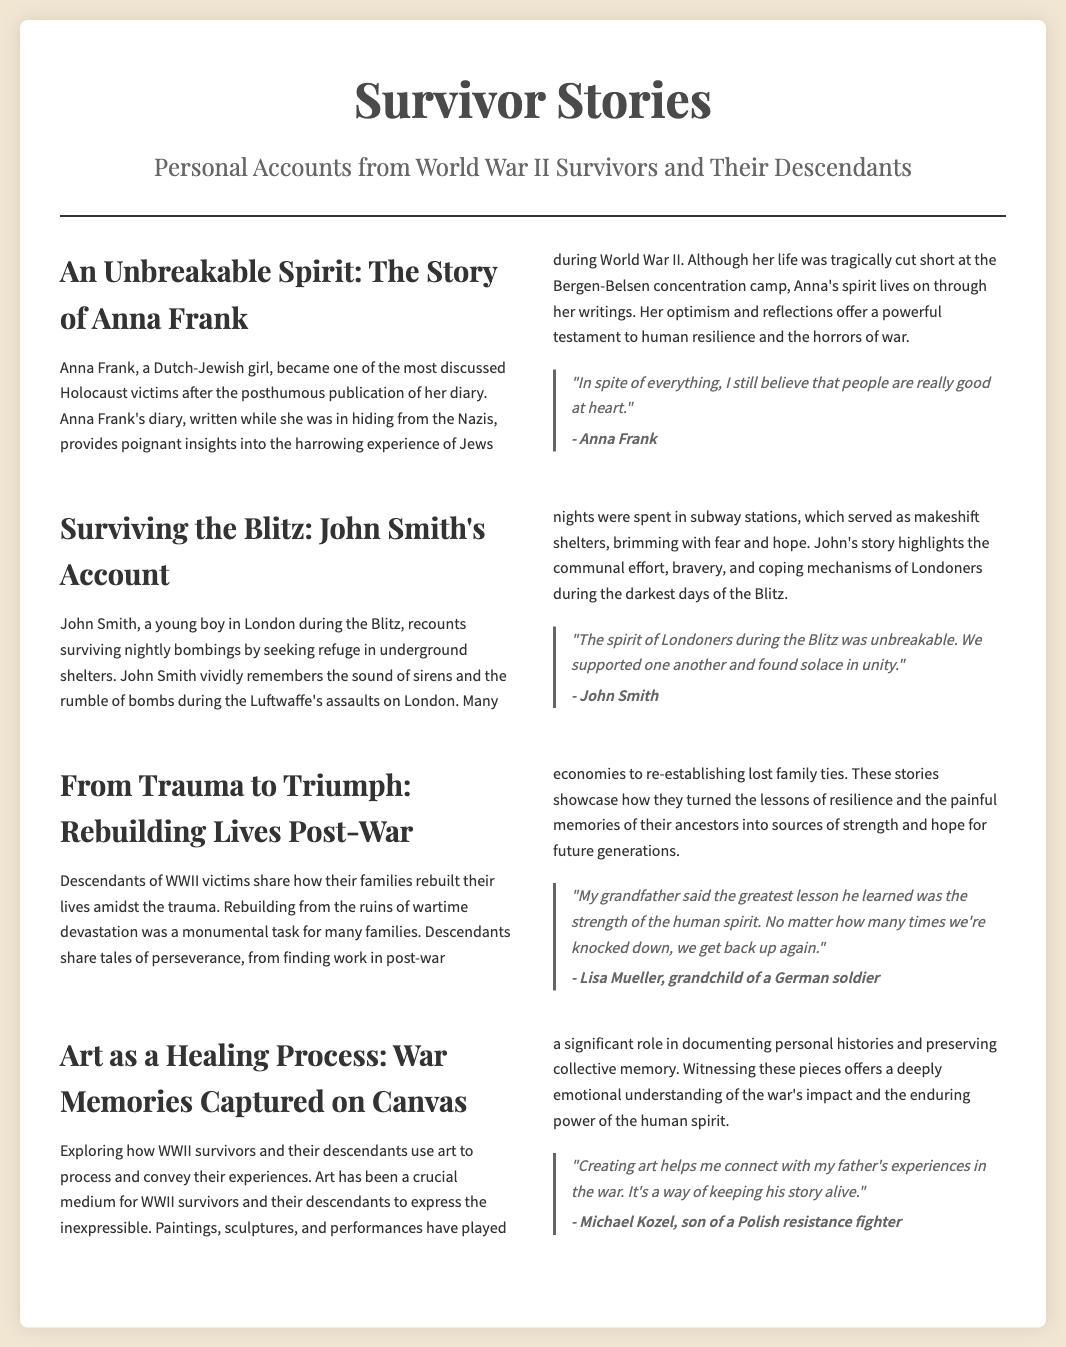What is the title of the article? The title of the article is prominently displayed at the top of the document.
Answer: Survivor Stories Who is the author of the quote about believing in goodness? The quote is attributed to Anna Frank, a significant figure discussed in the article.
Answer: Anna Frank What city did John Smith grow up in during WWII? The article specifically mentions John Smith's experiences during the Blitz in London.
Answer: London What lesson did Lisa Mueller's grandfather learn? The statements made in the article highlight the essence of the lesson learned by Lisa's grandfather.
Answer: The strength of the human spirit What artistic mediums are mentioned in the context of WWII survivors? The article lists various artistic means of expression used by survivors and descendants.
Answer: Paintings, sculptures, and performances How does Michael Kozel connect with his father's experiences? Michael's connection with his father's WWII experiences is emphasized through his artistic expression.
Answer: Creating art How many articles are included in the document's layout? The document contains multiple sections that tell different survivor stories.
Answer: Four 